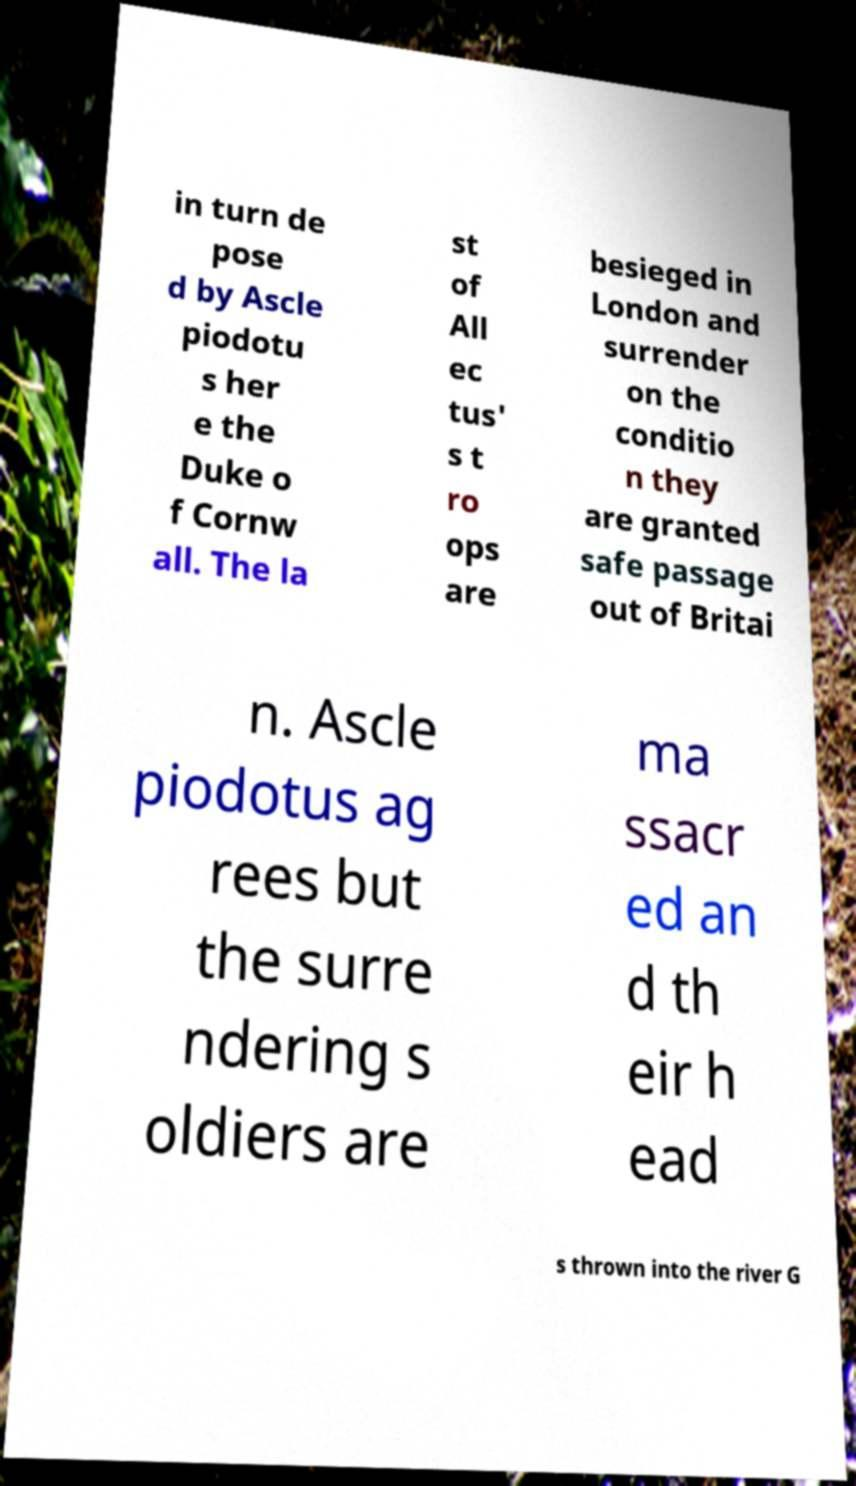I need the written content from this picture converted into text. Can you do that? in turn de pose d by Ascle piodotu s her e the Duke o f Cornw all. The la st of All ec tus' s t ro ops are besieged in London and surrender on the conditio n they are granted safe passage out of Britai n. Ascle piodotus ag rees but the surre ndering s oldiers are ma ssacr ed an d th eir h ead s thrown into the river G 